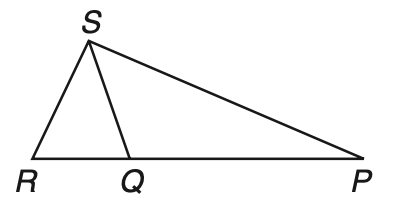Question: If P Q \cong Q S, Q R \cong R S, and m \angle P R S = 72, what is the measure of \angle Q P S?
Choices:
A. 27
B. 54
C. 63
D. 72
Answer with the letter. Answer: A 